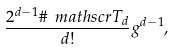<formula> <loc_0><loc_0><loc_500><loc_500>\frac { 2 ^ { d - 1 } \# \ m a t h s c r { T } _ { d } } { d ! } g ^ { d - 1 } ,</formula> 